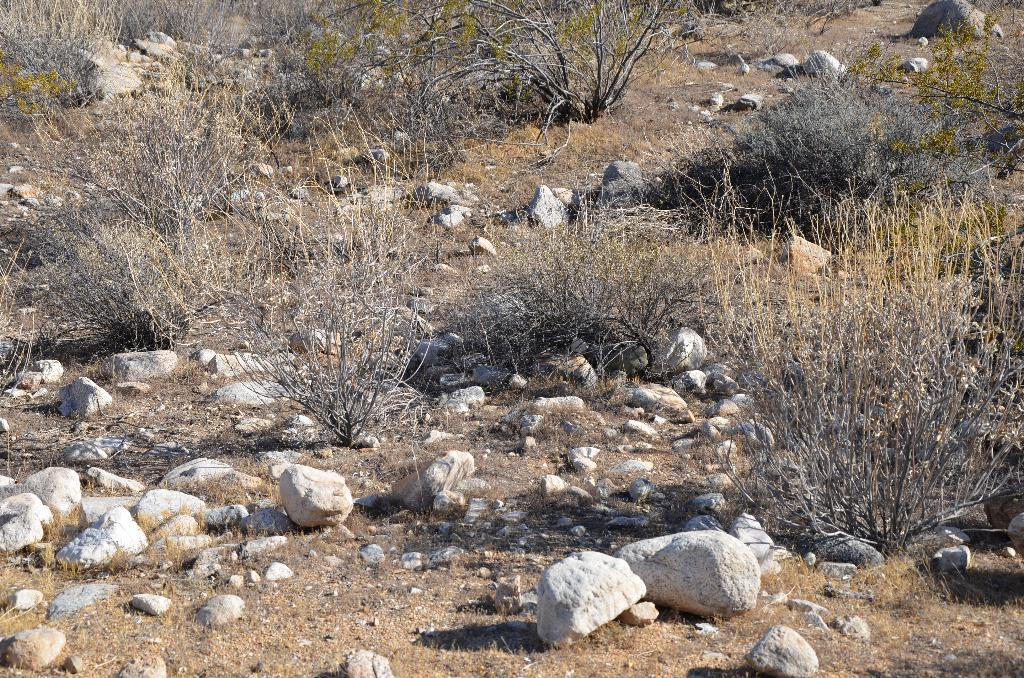What type of surface can be seen in the image? There is ground visible in the image. What objects are present on the ground? There are rocks in the image. What is the color of the rocks? The rocks are white and ash in color. What else can be seen in the image besides the rocks? There are plants in the image. Where are the toys placed in the image? There are no toys present in the image. What type of bed can be seen in the image? There is no bed present in the image. 